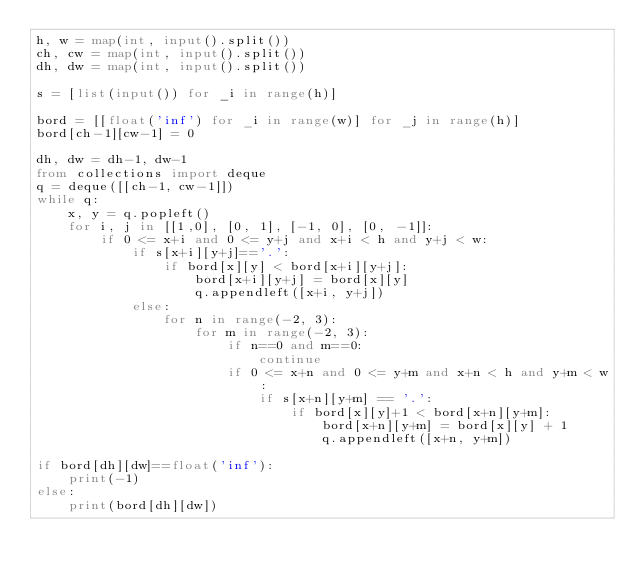Convert code to text. <code><loc_0><loc_0><loc_500><loc_500><_Python_>h, w = map(int, input().split())
ch, cw = map(int, input().split())
dh, dw = map(int, input().split())

s = [list(input()) for _i in range(h)]

bord = [[float('inf') for _i in range(w)] for _j in range(h)]
bord[ch-1][cw-1] = 0

dh, dw = dh-1, dw-1
from collections import deque
q = deque([[ch-1, cw-1]])
while q:
    x, y = q.popleft()
    for i, j in [[1,0], [0, 1], [-1, 0], [0, -1]]:
        if 0 <= x+i and 0 <= y+j and x+i < h and y+j < w:
            if s[x+i][y+j]=='.':
                if bord[x][y] < bord[x+i][y+j]:
                    bord[x+i][y+j] = bord[x][y]
                    q.appendleft([x+i, y+j])
            else:
                for n in range(-2, 3):
                    for m in range(-2, 3):
                        if n==0 and m==0:
                            continue
                        if 0 <= x+n and 0 <= y+m and x+n < h and y+m < w:
                            if s[x+n][y+m] == '.':
                                if bord[x][y]+1 < bord[x+n][y+m]:
                                    bord[x+n][y+m] = bord[x][y] + 1
                                    q.appendleft([x+n, y+m])

if bord[dh][dw]==float('inf'):
    print(-1)
else:
    print(bord[dh][dw])</code> 